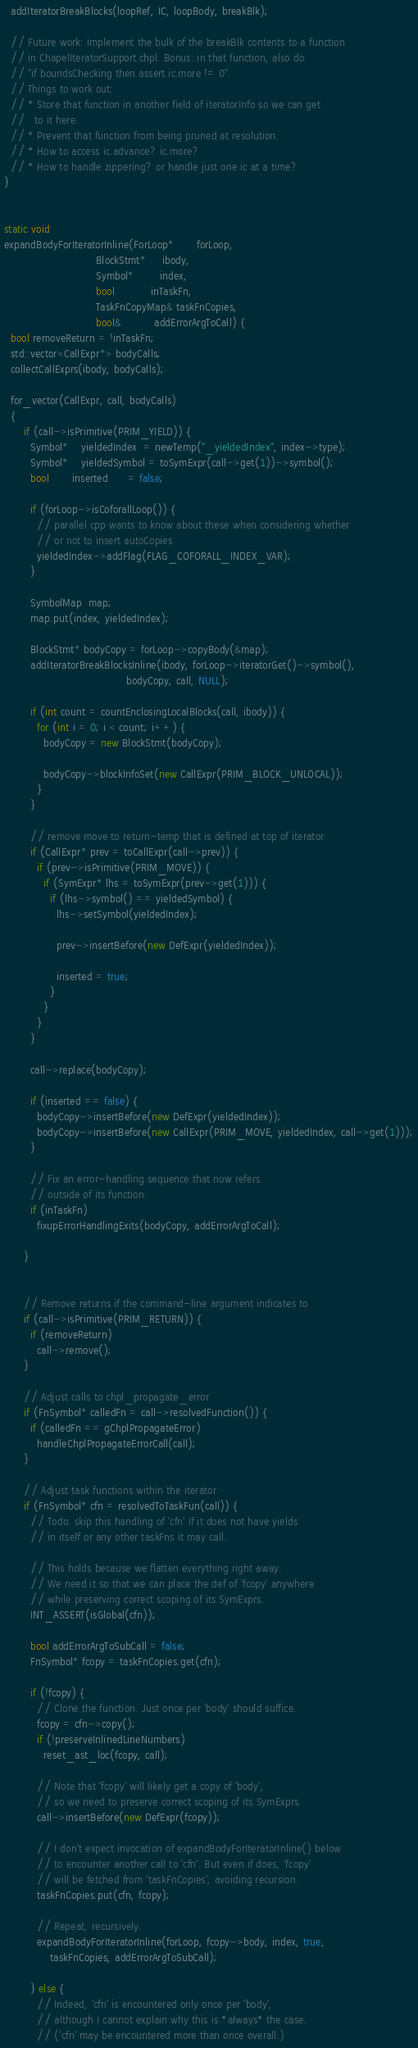<code> <loc_0><loc_0><loc_500><loc_500><_C++_>  addIteratorBreakBlocks(loopRef, IC, loopBody, breakBlk);

  // Future work: implement the bulk of the breakBlk contents to a function
  // in ChapelIteratorSupport.chpl. Bonus: in that function, also do
  // "if boundsChecking then assert ic.more != 0".
  // Things to work out:
  // * Store that function in another field of iteratorInfo so we can get
  //   to it here.
  // * Prevent that function from being pruned at resolution.
  // * How to access ic.advance? ic.more?
  // * How to handle zippering? or handle just one ic at a time?
}


static void
expandBodyForIteratorInline(ForLoop*       forLoop,
                            BlockStmt*     ibody,
                            Symbol*        index,
                            bool           inTaskFn,
                            TaskFnCopyMap& taskFnCopies,
                            bool&          addErrorArgToCall) {
  bool removeReturn = !inTaskFn;
  std::vector<CallExpr*> bodyCalls;
  collectCallExprs(ibody, bodyCalls);

  for_vector(CallExpr, call, bodyCalls)
  {
      if (call->isPrimitive(PRIM_YIELD)) {
        Symbol*    yieldedIndex  = newTemp("_yieldedIndex", index->type);
        Symbol*    yieldedSymbol = toSymExpr(call->get(1))->symbol();
        bool       inserted      = false;

        if (forLoop->isCoforallLoop()) {
          // parallel.cpp wants to know about these when considering whether
          // or not to insert autoCopies
          yieldedIndex->addFlag(FLAG_COFORALL_INDEX_VAR);
        }

        SymbolMap  map;
        map.put(index, yieldedIndex);

        BlockStmt* bodyCopy = forLoop->copyBody(&map);
        addIteratorBreakBlocksInline(ibody, forLoop->iteratorGet()->symbol(),
                                     bodyCopy, call, NULL);
        
        if (int count = countEnclosingLocalBlocks(call, ibody)) {
          for (int i = 0; i < count; i++) {
            bodyCopy = new BlockStmt(bodyCopy);

            bodyCopy->blockInfoSet(new CallExpr(PRIM_BLOCK_UNLOCAL));
          }
        }

        // remove move to return-temp that is defined at top of iterator
        if (CallExpr* prev = toCallExpr(call->prev)) {
          if (prev->isPrimitive(PRIM_MOVE)) {
            if (SymExpr* lhs = toSymExpr(prev->get(1))) {
              if (lhs->symbol() == yieldedSymbol) {
                lhs->setSymbol(yieldedIndex);

                prev->insertBefore(new DefExpr(yieldedIndex));

                inserted = true;
              }
            }
          }
        }

        call->replace(bodyCopy);

        if (inserted == false) {
          bodyCopy->insertBefore(new DefExpr(yieldedIndex));
          bodyCopy->insertBefore(new CallExpr(PRIM_MOVE, yieldedIndex, call->get(1)));
        }

        // Fix an error-handling sequence that now refers
        // outside of its function.
        if (inTaskFn)
          fixupErrorHandlingExits(bodyCopy, addErrorArgToCall);

      }


      // Remove returns if the command-line argument indicates to
      if (call->isPrimitive(PRIM_RETURN)) {
        if (removeReturn)
          call->remove();
      }

      // Adjust calls to chpl_propagate_error
      if (FnSymbol* calledFn = call->resolvedFunction()) {
        if (calledFn == gChplPropagateError)
          handleChplPropagateErrorCall(call);
      }

      // Adjust task functions within the iterator
      if (FnSymbol* cfn = resolvedToTaskFun(call)) {
        // Todo: skip this handling of 'cfn' if it does not have yields
        // in itself or any other taskFns it may call.

        // This holds because we flatten everything right away.
        // We need it so that we can place the def of 'fcopy' anywhere
        // while preserving correct scoping of its SymExprs.
        INT_ASSERT(isGlobal(cfn));

        bool addErrorArgToSubCall = false;
        FnSymbol* fcopy = taskFnCopies.get(cfn);

        if (!fcopy) {
          // Clone the function. Just once per 'body' should suffice.
          fcopy = cfn->copy();
          if (!preserveInlinedLineNumbers)
            reset_ast_loc(fcopy, call);

          // Note that 'fcopy' will likely get a copy of 'body',
          // so we need to preserve correct scoping of its SymExprs.
          call->insertBefore(new DefExpr(fcopy));

          // I don't expect invocation of expandBodyForIteratorInline() below
          // to encounter another call to 'cfn'. But even if does, 'fcopy'
          // will be fetched from 'taskFnCopies', avoiding recursion.
          taskFnCopies.put(cfn, fcopy);

          // Repeat, recursively.
          expandBodyForIteratorInline(forLoop, fcopy->body, index, true,
              taskFnCopies, addErrorArgToSubCall);

        } else {
          // Indeed, 'cfn' is encountered only once per 'body',
          // although I cannot explain why this is *always* the case.
          // ('cfn' may be encountered more than once overall.)</code> 